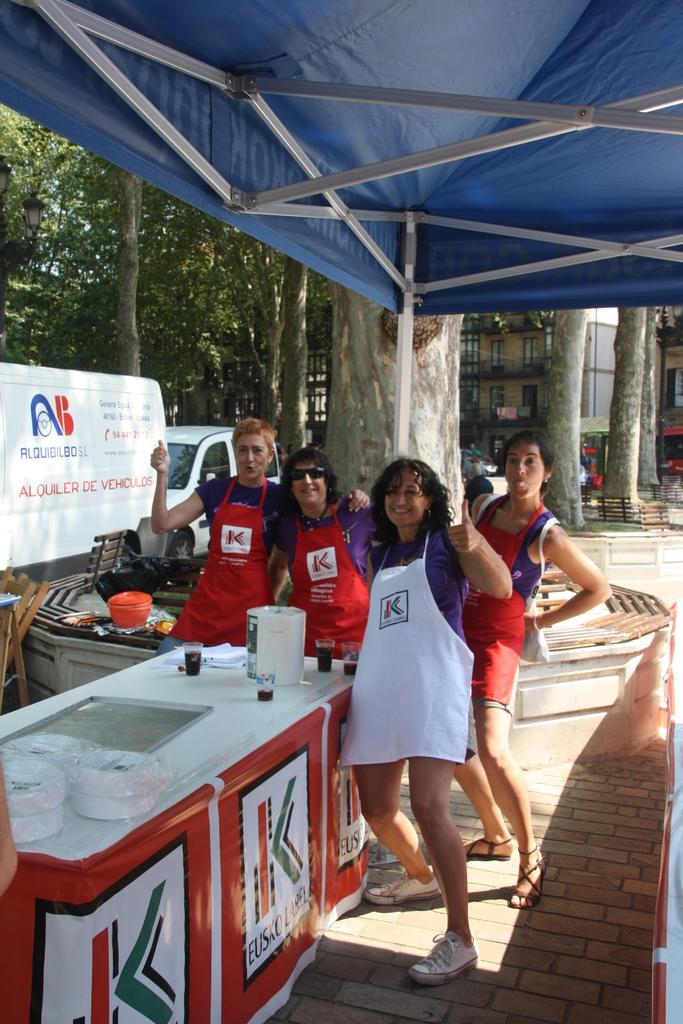Provide a one-sentence caption for the provided image. A group of workers wearing aprons that have the letter K on them. 